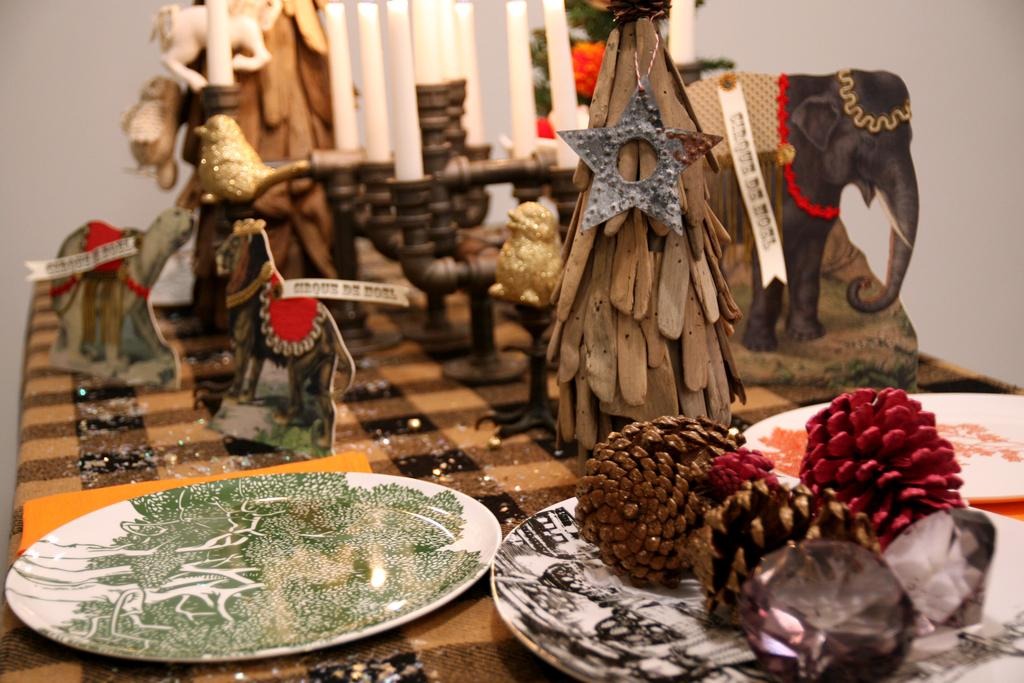What type of objects can be seen in the image? There are candles, decorative items, and plates in the image. What is covering the table in the image? There is a cloth on the table in the image. What can be seen in the background of the image? There is a plant and a wall in the background of the image. What direction is the structure being developed in the image? There is no structure being developed in the image, nor any indication of a development process. 